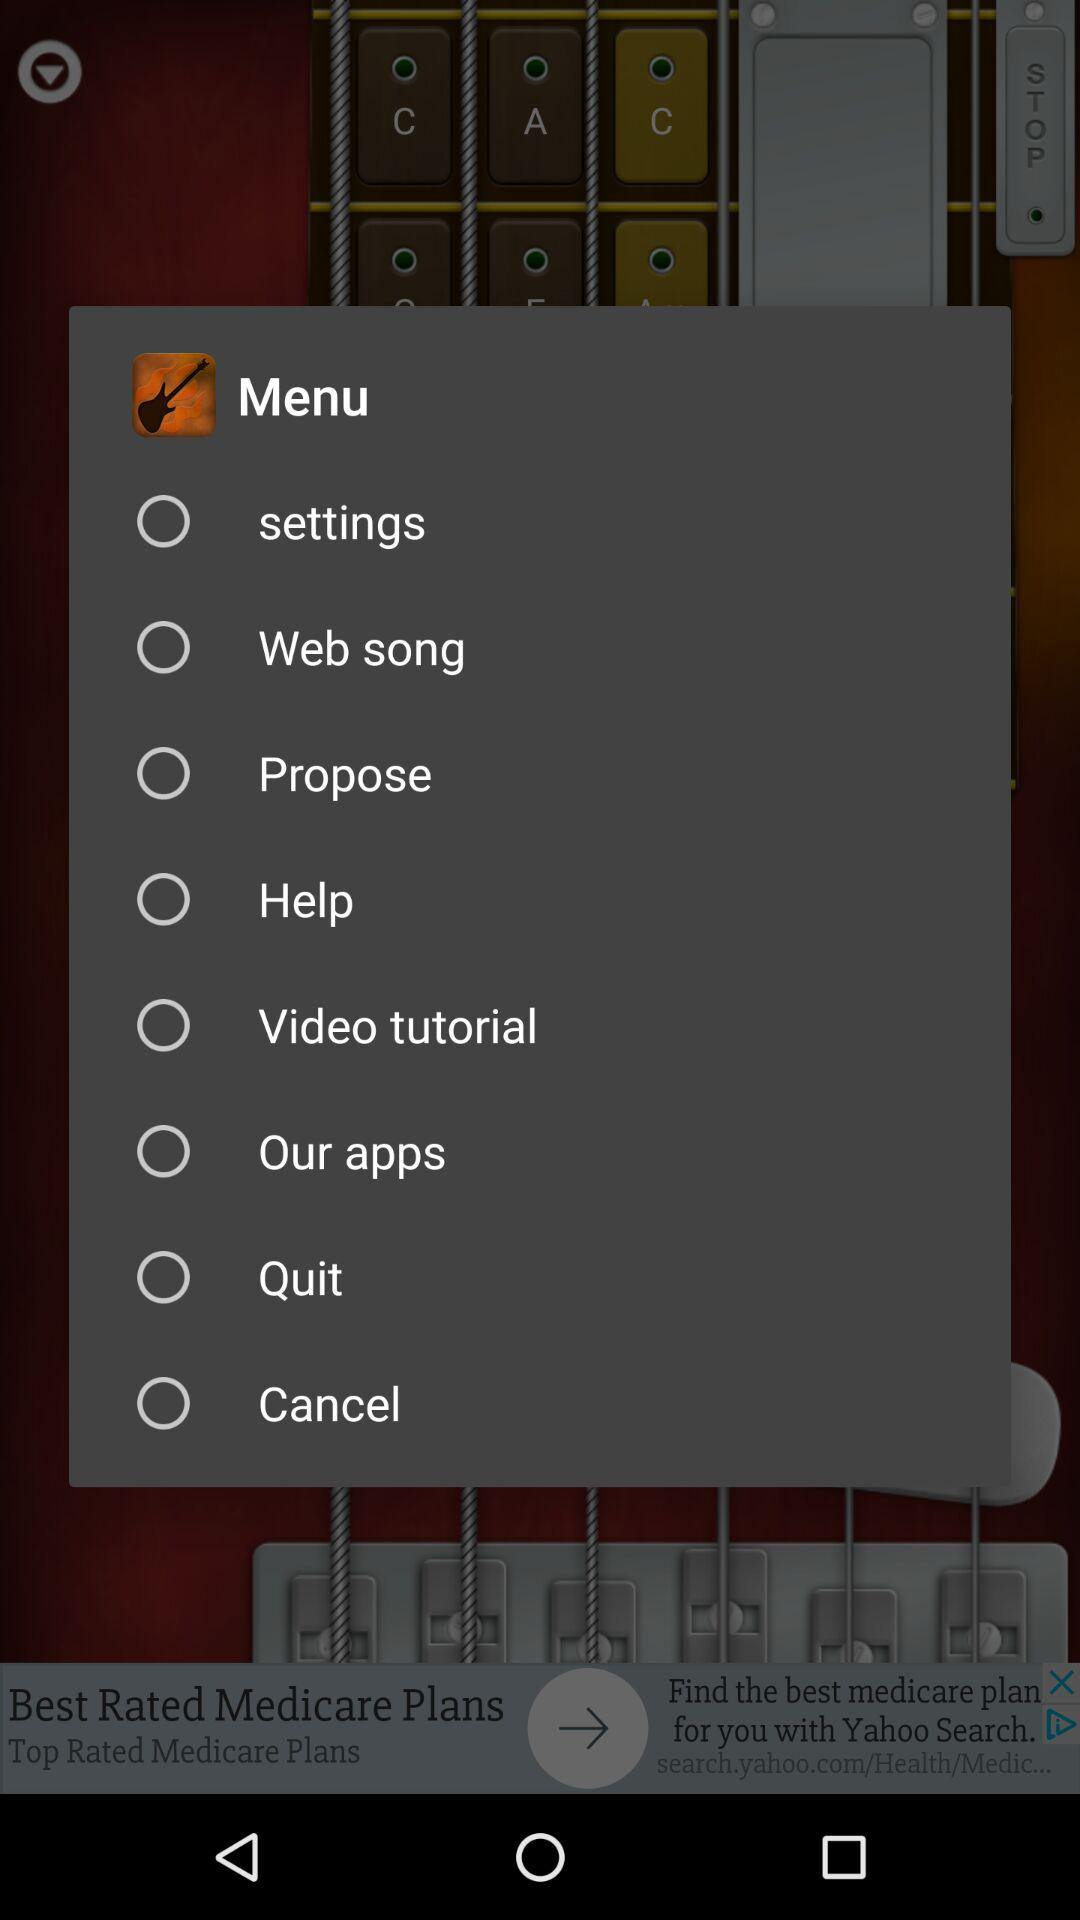Which menu option is selected?
When the provided information is insufficient, respond with <no answer>. <no answer> 